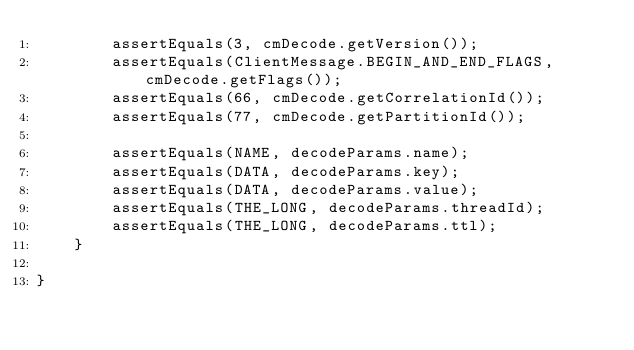<code> <loc_0><loc_0><loc_500><loc_500><_Java_>        assertEquals(3, cmDecode.getVersion());
        assertEquals(ClientMessage.BEGIN_AND_END_FLAGS, cmDecode.getFlags());
        assertEquals(66, cmDecode.getCorrelationId());
        assertEquals(77, cmDecode.getPartitionId());

        assertEquals(NAME, decodeParams.name);
        assertEquals(DATA, decodeParams.key);
        assertEquals(DATA, decodeParams.value);
        assertEquals(THE_LONG, decodeParams.threadId);
        assertEquals(THE_LONG, decodeParams.ttl);
    }

}
</code> 